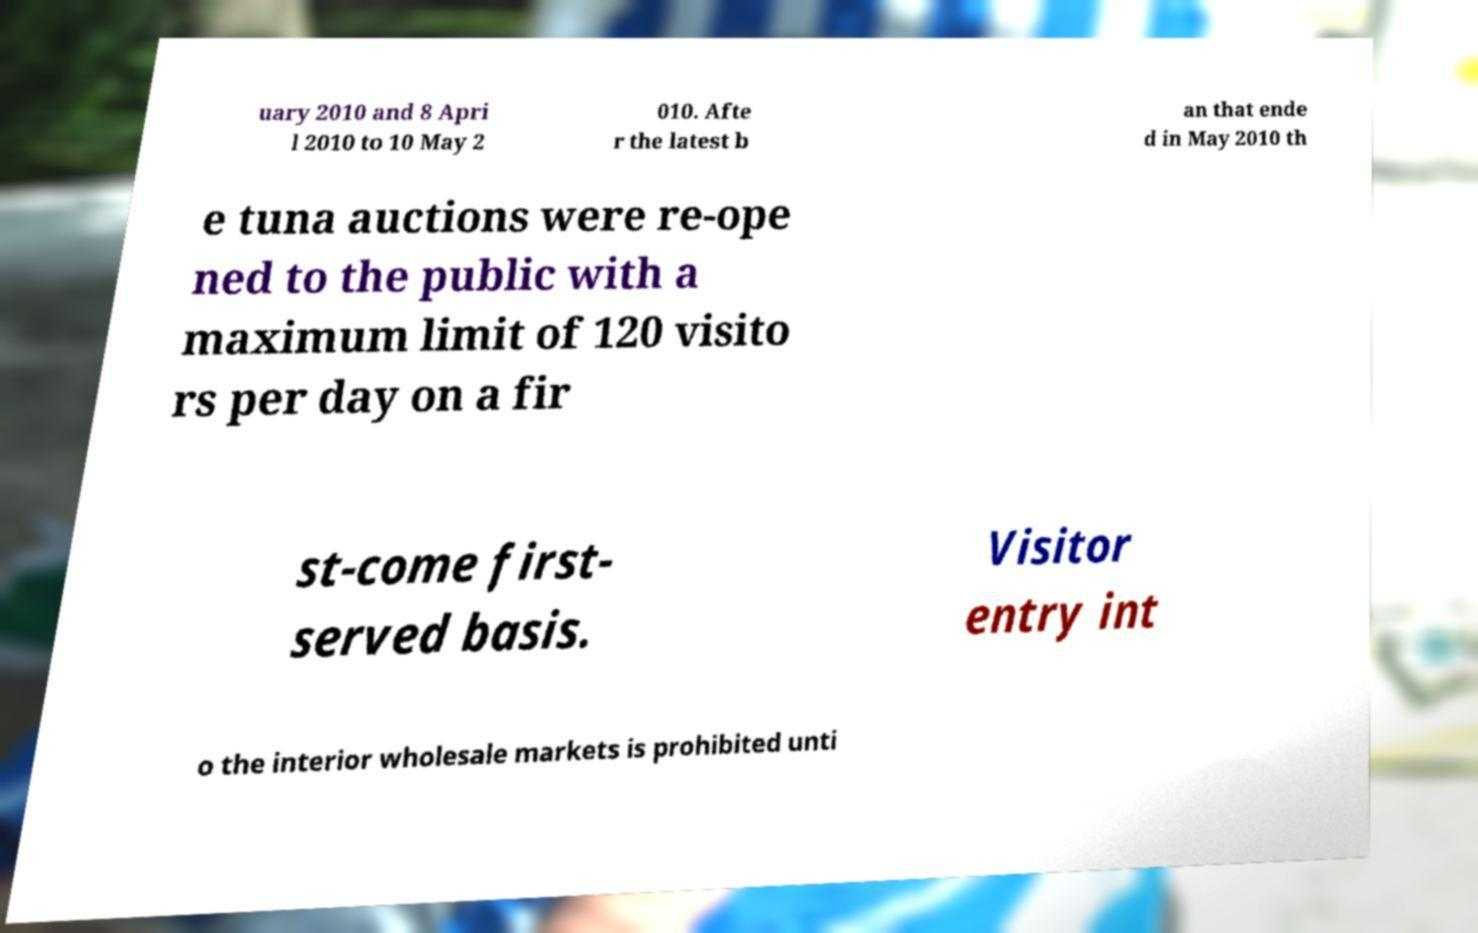I need the written content from this picture converted into text. Can you do that? uary 2010 and 8 Apri l 2010 to 10 May 2 010. Afte r the latest b an that ende d in May 2010 th e tuna auctions were re-ope ned to the public with a maximum limit of 120 visito rs per day on a fir st-come first- served basis. Visitor entry int o the interior wholesale markets is prohibited unti 